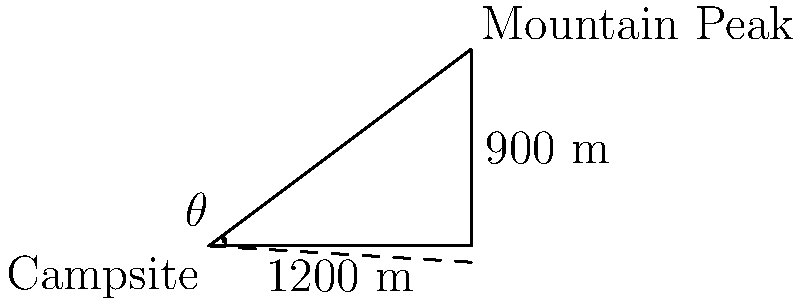At your campsite, you're planning to hike to a nearby mountain peak. The horizontal distance to the peak is 1200 meters, and the peak is 900 meters higher in elevation than your campsite. What is the angle of elevation (in degrees) from your campsite to the mountain peak? To find the angle of elevation, we can use trigonometry. Let's approach this step-by-step:

1) We have a right triangle where:
   - The adjacent side (horizontal distance) is 1200 meters
   - The opposite side (elevation difference) is 900 meters
   - We need to find the angle θ

2) In a right triangle, tan(θ) = opposite / adjacent

3) Substituting our values:
   tan(θ) = 900 / 1200

4) To find θ, we need to use the inverse tangent (arctan or tan^(-1)):
   θ = arctan(900 / 1200)

5) Let's calculate:
   θ = arctan(0.75)
   θ ≈ 36.87 degrees

6) Rounding to the nearest degree:
   θ ≈ 37 degrees

Therefore, the angle of elevation from your campsite to the mountain peak is approximately 37 degrees.
Answer: 37° 